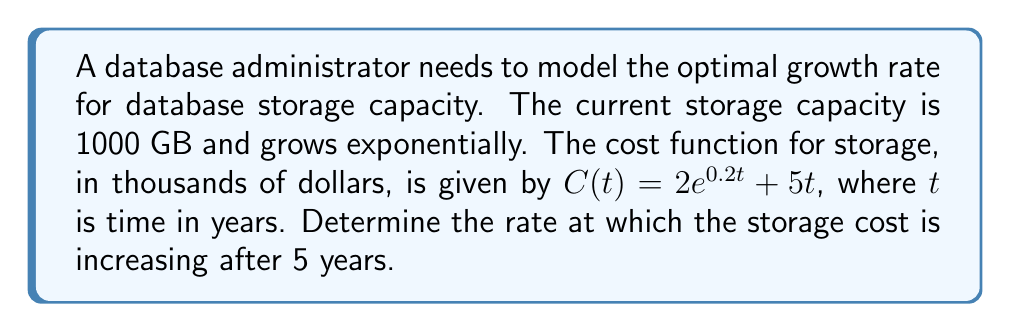Could you help me with this problem? To find the rate at which the storage cost is increasing after 5 years, we need to calculate the derivative of the cost function and evaluate it at $t = 5$.

1. Given cost function: $C(t) = 2e^{0.2t} + 5t$

2. Calculate the derivative of $C(t)$ with respect to $t$:
   $$\frac{dC}{dt} = 2 \cdot 0.2e^{0.2t} + 5$$
   $$\frac{dC}{dt} = 0.4e^{0.2t} + 5$$

3. Evaluate the derivative at $t = 5$:
   $$\frac{dC}{dt}\bigg|_{t=5} = 0.4e^{0.2(5)} + 5$$
   $$= 0.4e^{1} + 5$$
   $$= 0.4 \cdot 2.71828 + 5$$
   $$= 1.08731 + 5$$
   $$= 6.08731$$

4. Interpret the result:
   The rate of increase in storage cost after 5 years is approximately 6.08731 thousand dollars per year.
Answer: $6.08731$ thousand dollars per year 